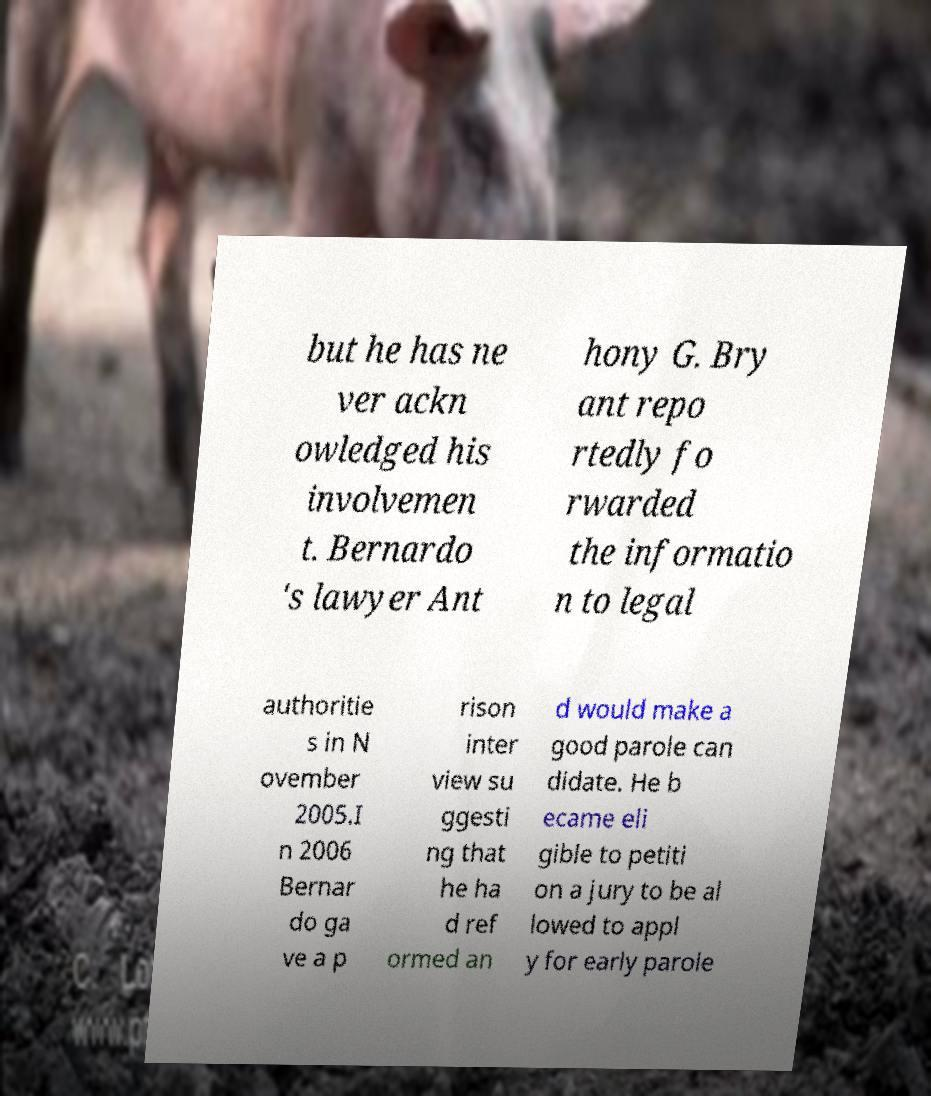Can you read and provide the text displayed in the image?This photo seems to have some interesting text. Can you extract and type it out for me? but he has ne ver ackn owledged his involvemen t. Bernardo 's lawyer Ant hony G. Bry ant repo rtedly fo rwarded the informatio n to legal authoritie s in N ovember 2005.I n 2006 Bernar do ga ve a p rison inter view su ggesti ng that he ha d ref ormed an d would make a good parole can didate. He b ecame eli gible to petiti on a jury to be al lowed to appl y for early parole 